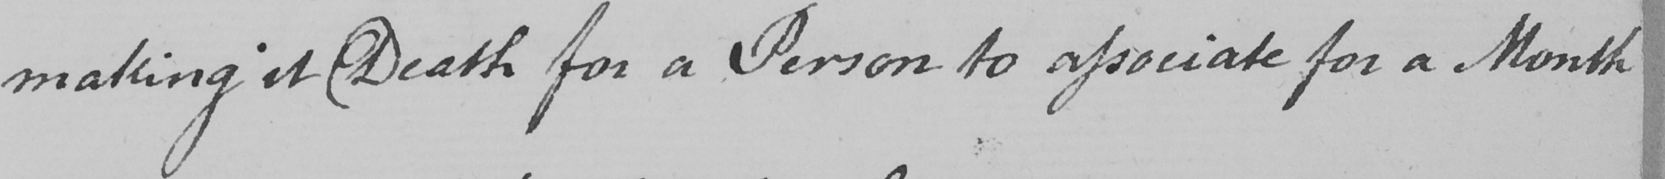What does this handwritten line say? making it Death for a Person to associate for a Month 